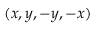<formula> <loc_0><loc_0><loc_500><loc_500>( x , y , - y , - x )</formula> 